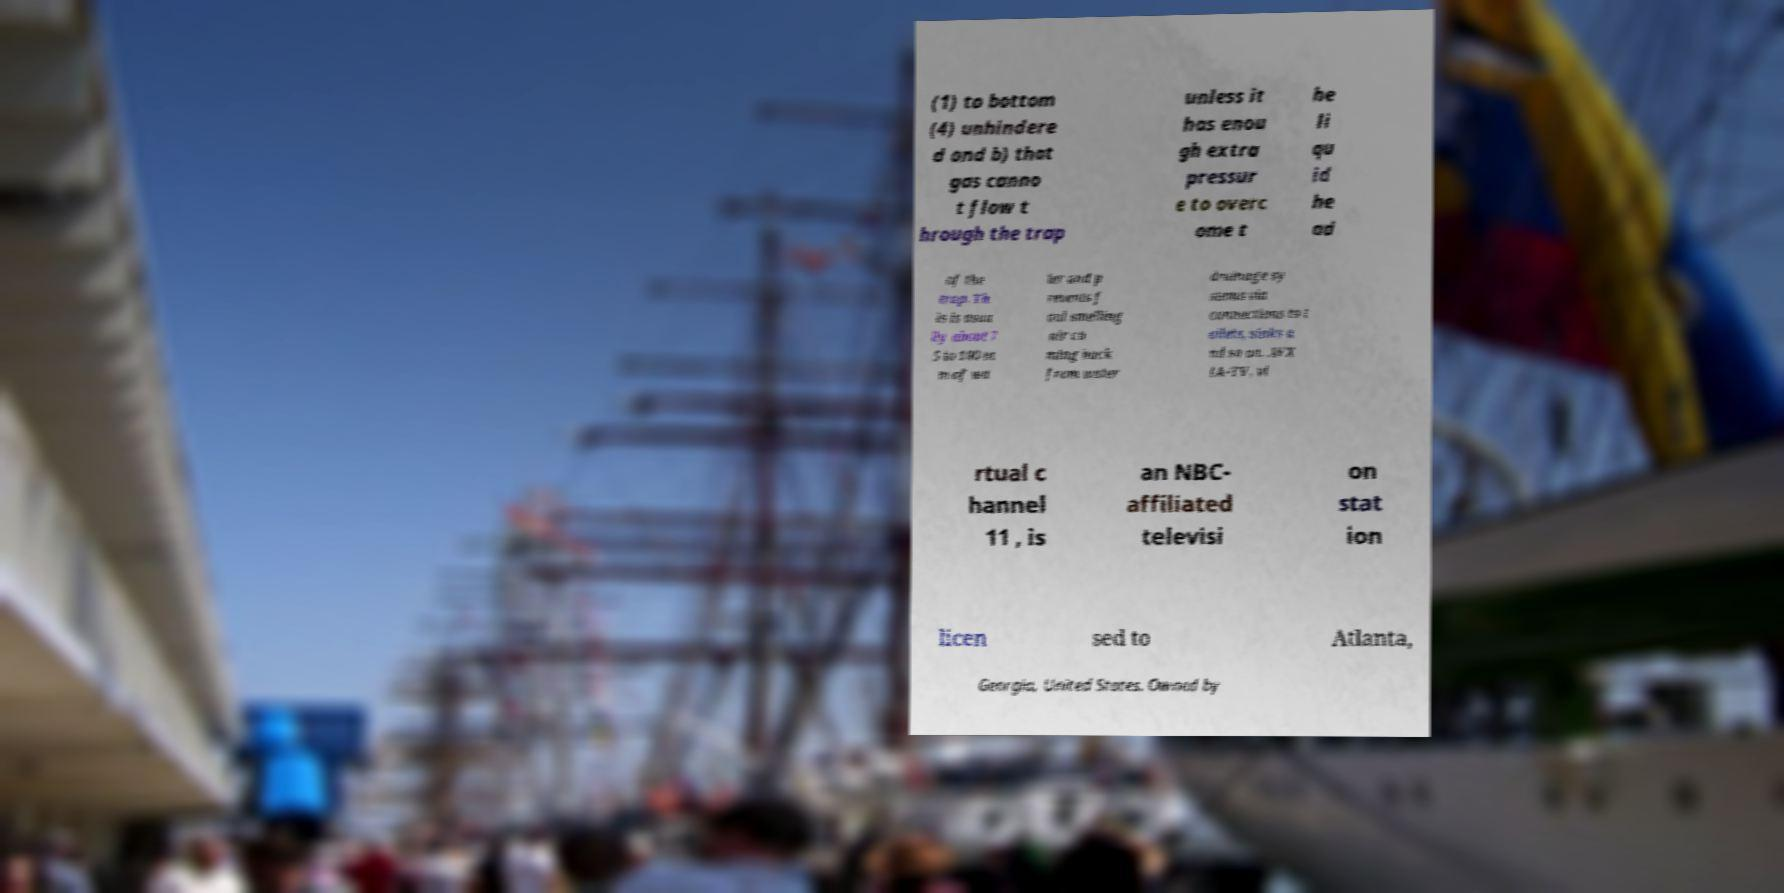Can you read and provide the text displayed in the image?This photo seems to have some interesting text. Can you extract and type it out for me? (1) to bottom (4) unhindere d and b) that gas canno t flow t hrough the trap unless it has enou gh extra pressur e to overc ome t he li qu id he ad of the trap. Th is is usua lly about 7 5 to 100 m m of wa ter and p revents f oul smelling air co ming back from water drainage sy stems via connections to t oilets, sinks a nd so on. .WX IA-TV, vi rtual c hannel 11 , is an NBC- affiliated televisi on stat ion licen sed to Atlanta, Georgia, United States. Owned by 